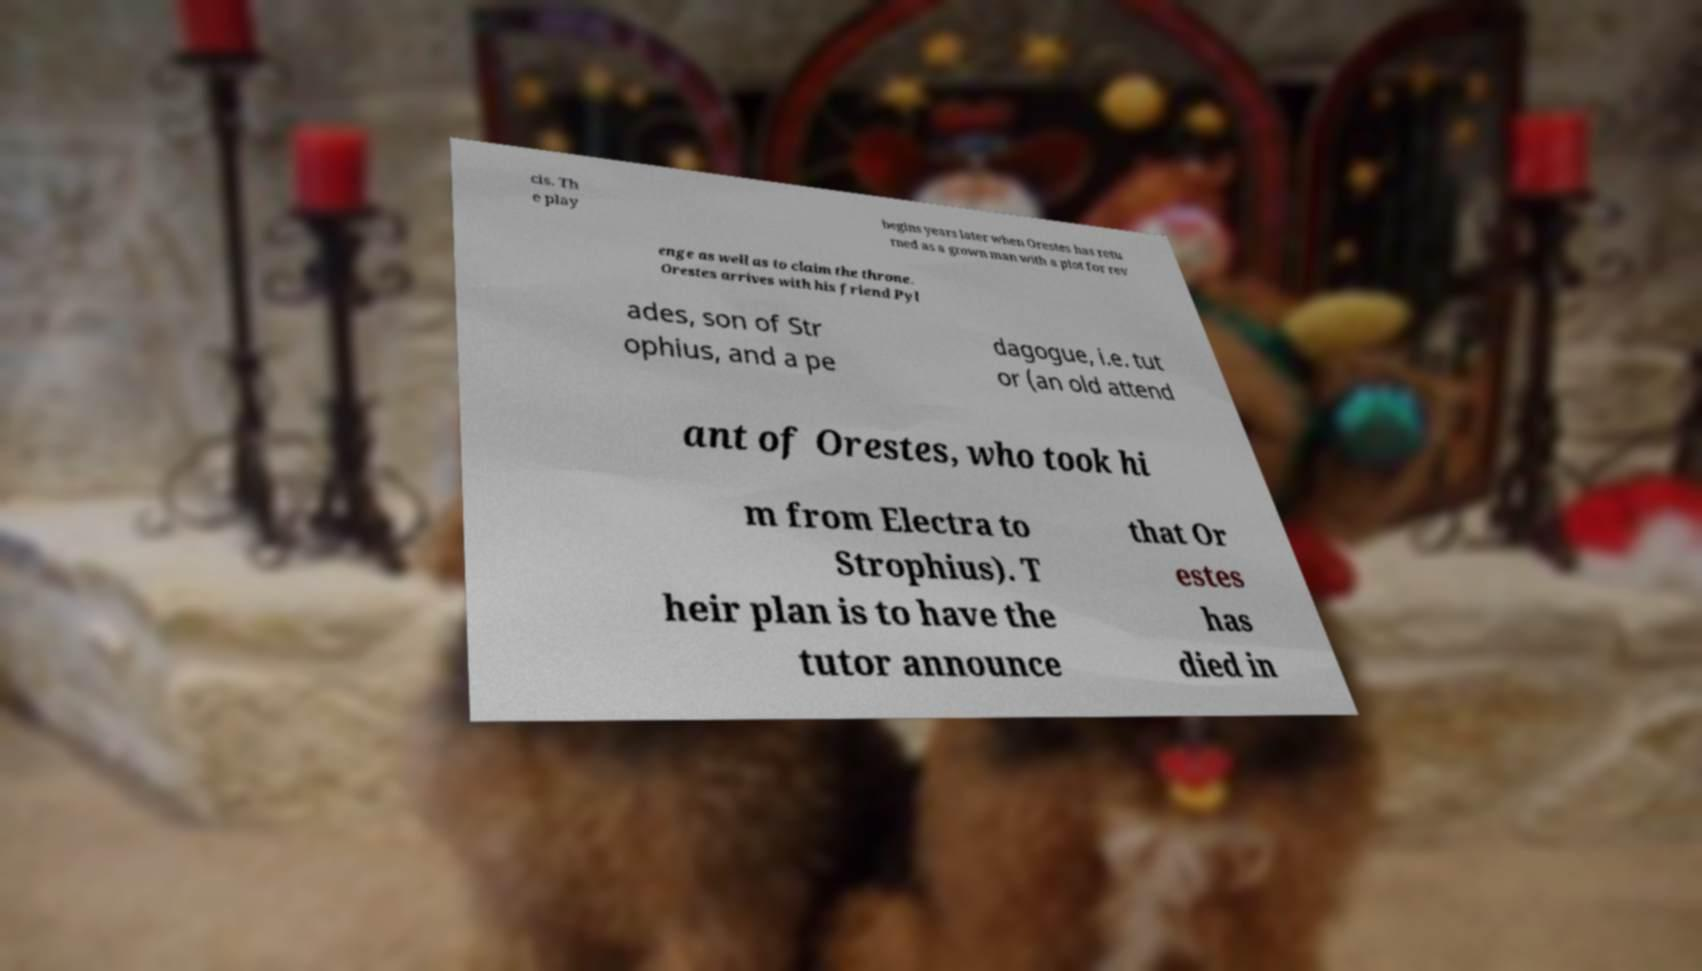There's text embedded in this image that I need extracted. Can you transcribe it verbatim? cis. Th e play begins years later when Orestes has retu rned as a grown man with a plot for rev enge as well as to claim the throne. Orestes arrives with his friend Pyl ades, son of Str ophius, and a pe dagogue, i.e. tut or (an old attend ant of Orestes, who took hi m from Electra to Strophius). T heir plan is to have the tutor announce that Or estes has died in 